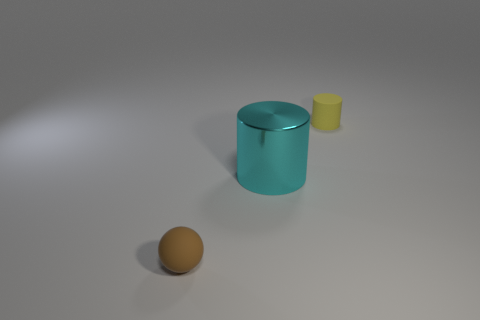There is a large cyan thing; are there any cyan metal cylinders to the left of it?
Offer a terse response. No. Are there any shiny objects that have the same color as the big metal cylinder?
Give a very brief answer. No. What number of big things are either cyan metal things or brown spheres?
Your response must be concise. 1. Is the material of the thing that is on the left side of the big cyan cylinder the same as the cyan thing?
Offer a very short reply. No. There is a tiny thing in front of the rubber thing that is behind the small rubber thing that is on the left side of the yellow cylinder; what is its shape?
Provide a short and direct response. Sphere. What number of red things are either large metallic cylinders or matte cylinders?
Provide a succinct answer. 0. Is the number of shiny things on the right side of the large cyan shiny cylinder the same as the number of cyan things that are on the left side of the brown sphere?
Keep it short and to the point. Yes. Does the tiny brown matte thing in front of the tiny yellow matte cylinder have the same shape as the tiny matte thing on the right side of the brown thing?
Provide a short and direct response. No. Are there any other things that are the same shape as the yellow matte object?
Keep it short and to the point. Yes. What shape is the brown thing that is made of the same material as the yellow cylinder?
Offer a terse response. Sphere. 